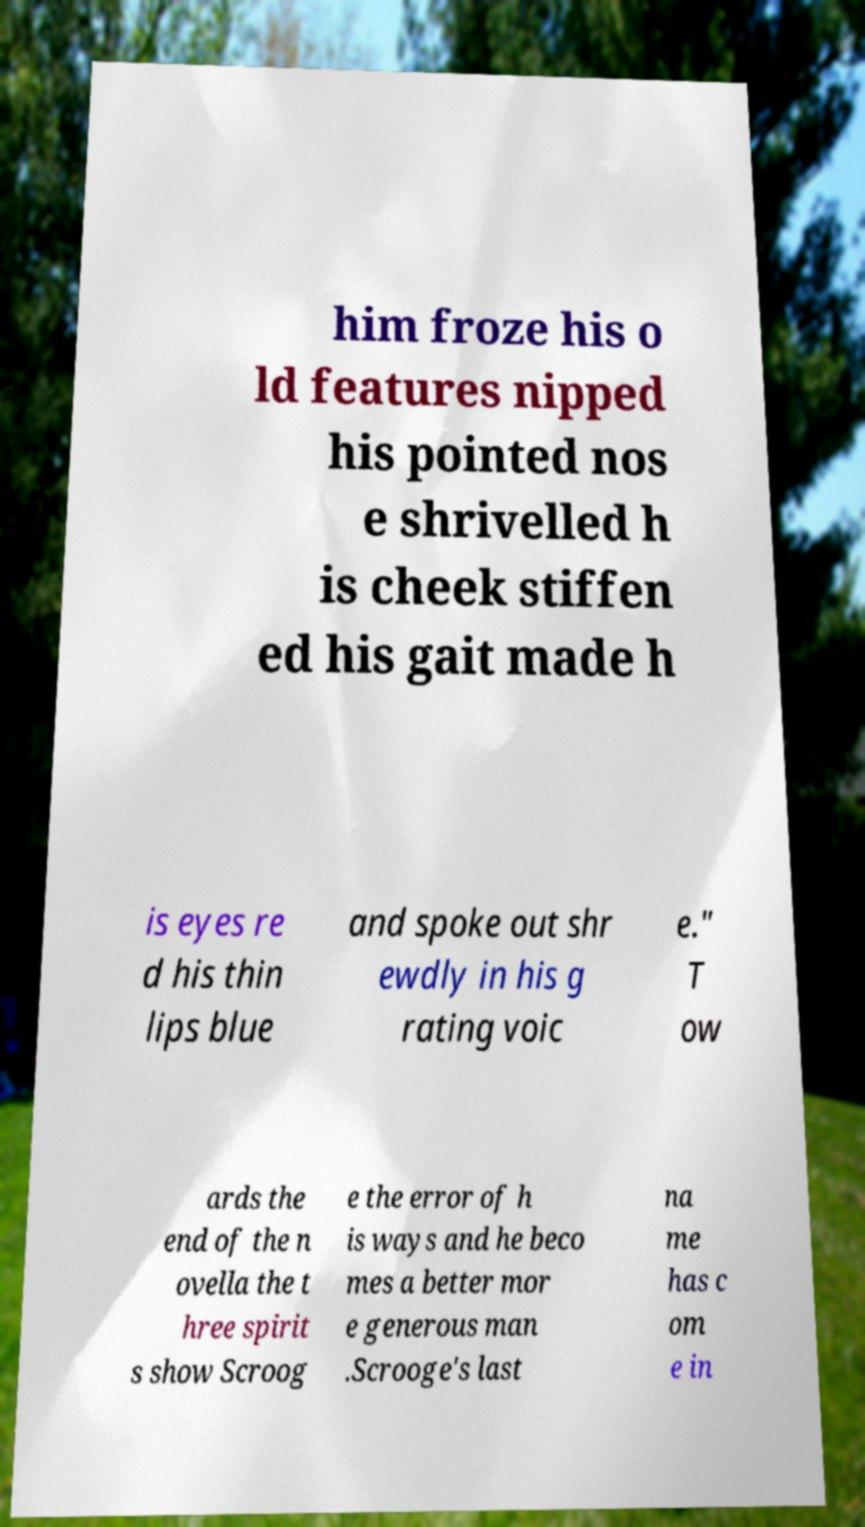For documentation purposes, I need the text within this image transcribed. Could you provide that? him froze his o ld features nipped his pointed nos e shrivelled h is cheek stiffen ed his gait made h is eyes re d his thin lips blue and spoke out shr ewdly in his g rating voic e." T ow ards the end of the n ovella the t hree spirit s show Scroog e the error of h is ways and he beco mes a better mor e generous man .Scrooge's last na me has c om e in 